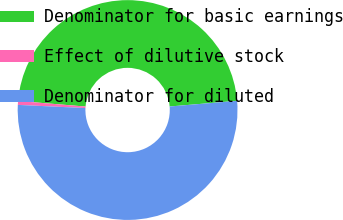<chart> <loc_0><loc_0><loc_500><loc_500><pie_chart><fcel>Denominator for basic earnings<fcel>Effect of dilutive stock<fcel>Denominator for diluted<nl><fcel>47.35%<fcel>0.57%<fcel>52.08%<nl></chart> 